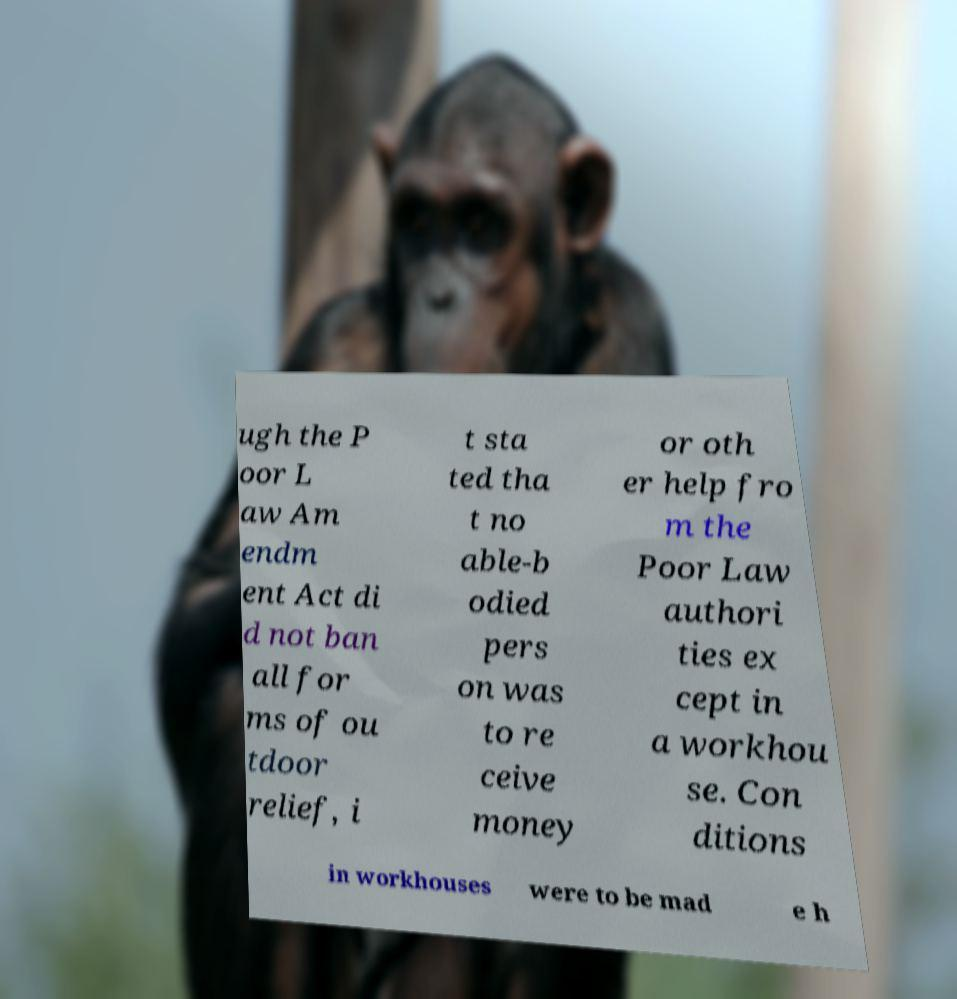For documentation purposes, I need the text within this image transcribed. Could you provide that? ugh the P oor L aw Am endm ent Act di d not ban all for ms of ou tdoor relief, i t sta ted tha t no able-b odied pers on was to re ceive money or oth er help fro m the Poor Law authori ties ex cept in a workhou se. Con ditions in workhouses were to be mad e h 